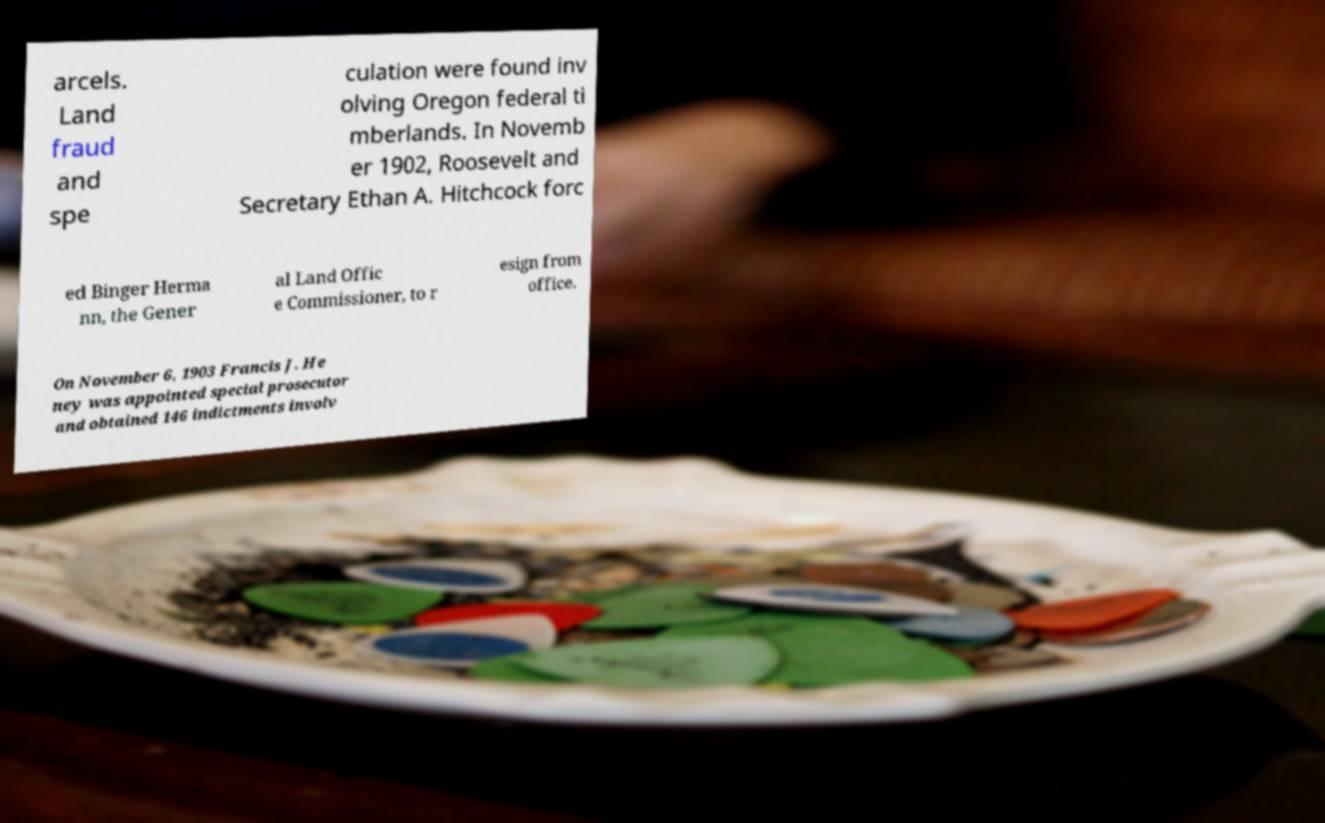I need the written content from this picture converted into text. Can you do that? arcels. Land fraud and spe culation were found inv olving Oregon federal ti mberlands. In Novemb er 1902, Roosevelt and Secretary Ethan A. Hitchcock forc ed Binger Herma nn, the Gener al Land Offic e Commissioner, to r esign from office. On November 6, 1903 Francis J. He ney was appointed special prosecutor and obtained 146 indictments involv 